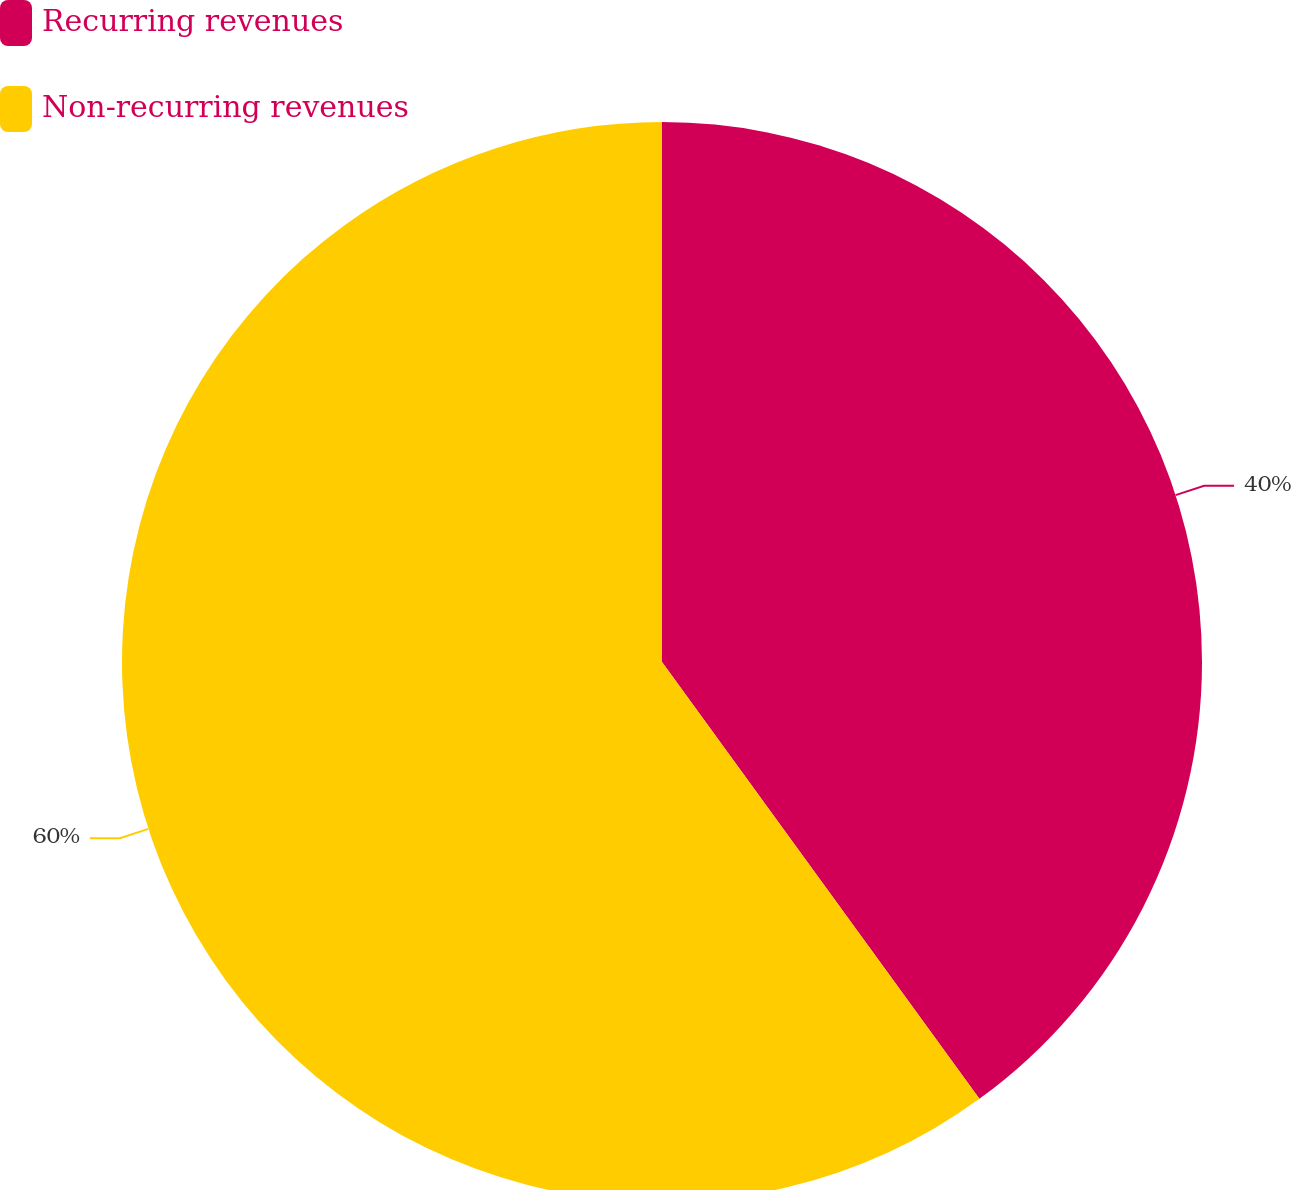Convert chart. <chart><loc_0><loc_0><loc_500><loc_500><pie_chart><fcel>Recurring revenues<fcel>Non-recurring revenues<nl><fcel>40.0%<fcel>60.0%<nl></chart> 